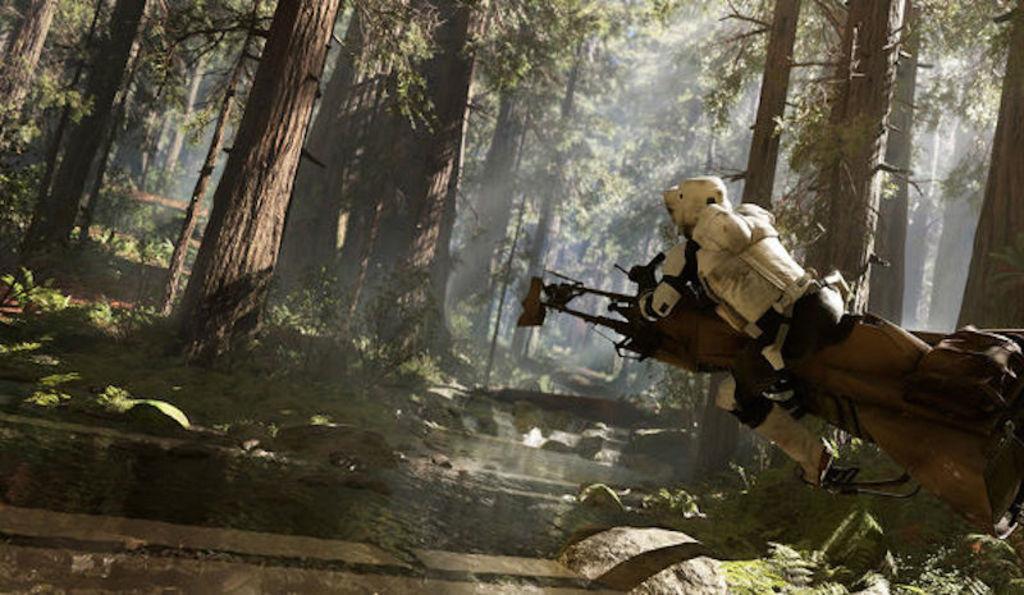Can you describe this image briefly? On the right side of the image there is a person wearing a white color jacket. In the background there are trees and some water. 